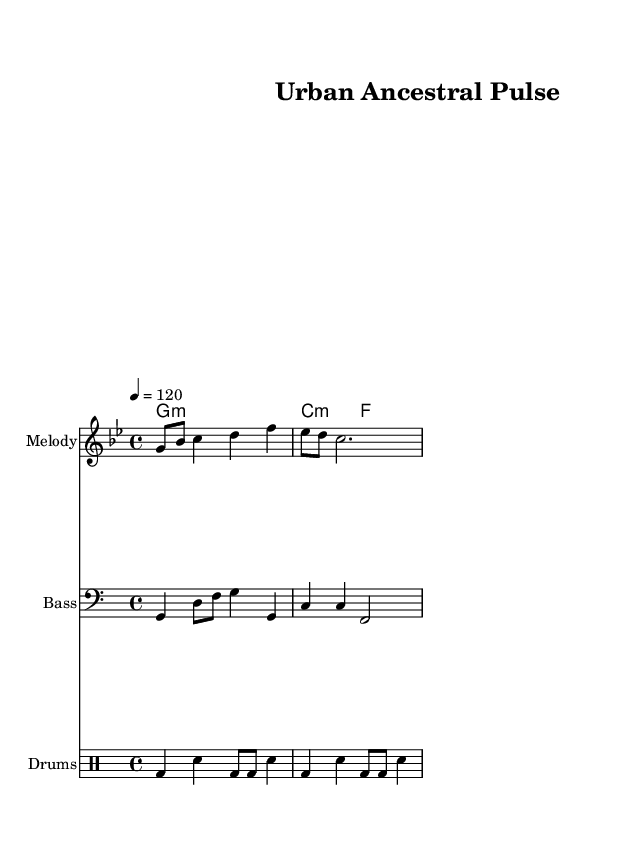What is the key signature of this music? The key signature indicated in the score shows that it is G minor, which typically has two flats (B flat and E flat).
Answer: G minor What is the time signature of this music? The time signature is shown at the beginning of the score as 4/4, meaning there are four beats in each measure and the quarter note gets one beat.
Answer: 4/4 What is the tempo marking for this piece? The tempo is indicated as "4 = 120", which means that there are 120 quarter notes played per minute.
Answer: 120 How many measures are in the melody? Counting the number of bar lines in the melody part reveals there are three measures.
Answer: 3 Identify the first note of the melody. The first note shown in the melody is G, which is the highest note in the first measure of the melody.
Answer: G What type of drum pattern is used in this music? The drum part follows a basic four-beat pattern with a kick drum and snare, resembling a traditional dance beat that integrates urban rhythms.
Answer: Dance beat What chords are used in the second measure? The chord symbols above the staff indicate that the second measure uses C minor and F minor chords.
Answer: C minor, F minor 